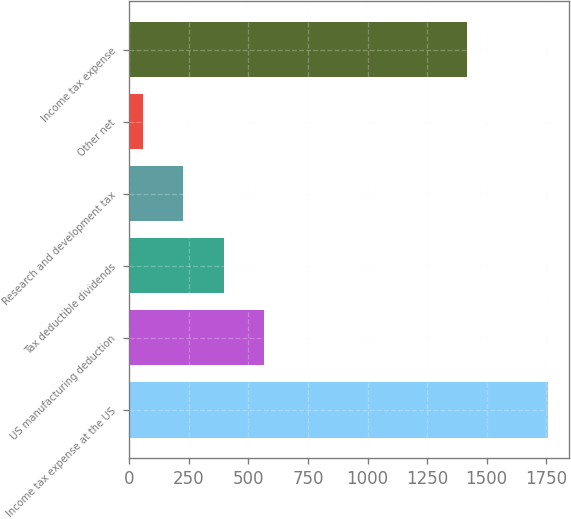Convert chart to OTSL. <chart><loc_0><loc_0><loc_500><loc_500><bar_chart><fcel>Income tax expense at the US<fcel>US manufacturing deduction<fcel>Tax deductible dividends<fcel>Research and development tax<fcel>Other net<fcel>Income tax expense<nl><fcel>1758<fcel>566.6<fcel>396.4<fcel>226.2<fcel>56<fcel>1418<nl></chart> 